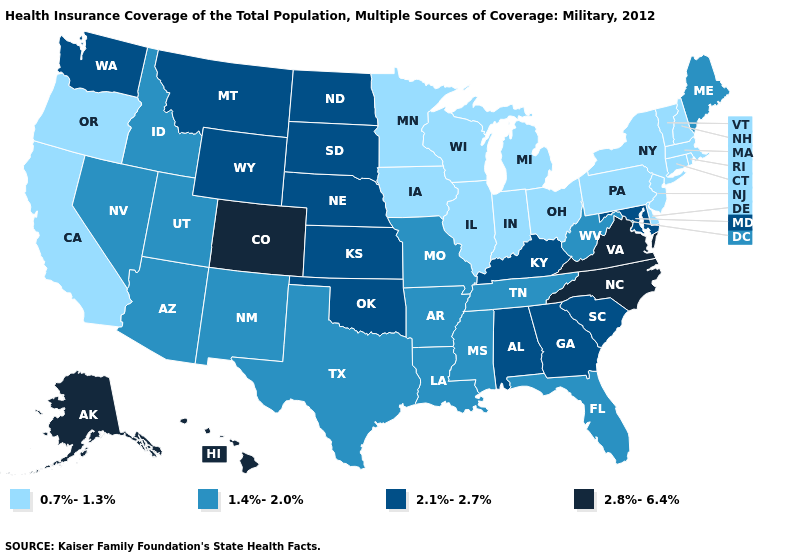Does Maine have the lowest value in the Northeast?
Short answer required. No. Does Oklahoma have a higher value than Vermont?
Answer briefly. Yes. Does Hawaii have the same value as Alaska?
Keep it brief. Yes. What is the value of Florida?
Be succinct. 1.4%-2.0%. What is the lowest value in states that border Mississippi?
Answer briefly. 1.4%-2.0%. What is the value of Arkansas?
Write a very short answer. 1.4%-2.0%. Name the states that have a value in the range 0.7%-1.3%?
Concise answer only. California, Connecticut, Delaware, Illinois, Indiana, Iowa, Massachusetts, Michigan, Minnesota, New Hampshire, New Jersey, New York, Ohio, Oregon, Pennsylvania, Rhode Island, Vermont, Wisconsin. Does Nebraska have the same value as Washington?
Keep it brief. Yes. Which states have the lowest value in the USA?
Give a very brief answer. California, Connecticut, Delaware, Illinois, Indiana, Iowa, Massachusetts, Michigan, Minnesota, New Hampshire, New Jersey, New York, Ohio, Oregon, Pennsylvania, Rhode Island, Vermont, Wisconsin. What is the value of Maryland?
Write a very short answer. 2.1%-2.7%. Does Pennsylvania have the highest value in the Northeast?
Keep it brief. No. What is the value of Pennsylvania?
Keep it brief. 0.7%-1.3%. Does Georgia have a higher value than Hawaii?
Write a very short answer. No. Does Illinois have the same value as Colorado?
Concise answer only. No. 